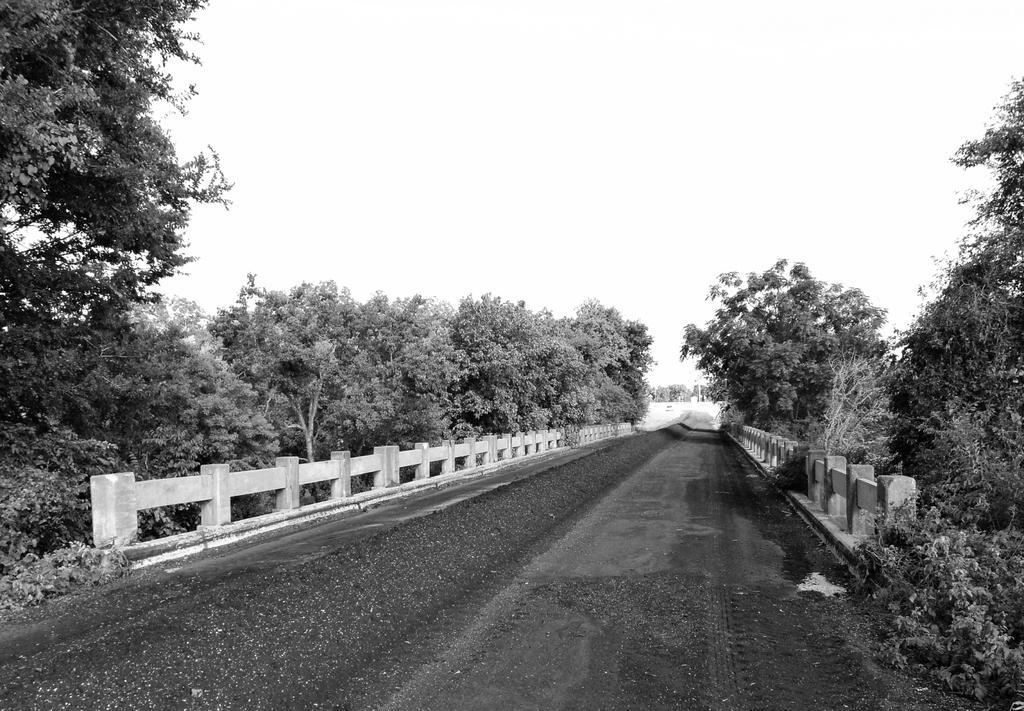Can you describe this image briefly? This is a black and white image, in this image there is a road, beside the road there is a concrete fence, on the either side of the fence there are trees. 